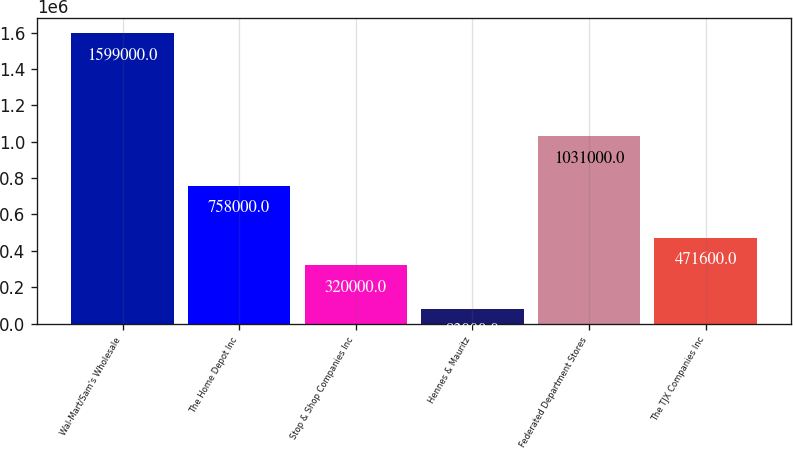<chart> <loc_0><loc_0><loc_500><loc_500><bar_chart><fcel>Wal-Mart/Sam's Wholesale<fcel>The Home Depot Inc<fcel>Stop & Shop Companies Inc<fcel>Hennes & Mauritz<fcel>Federated Department Stores<fcel>The TJX Companies Inc<nl><fcel>1.599e+06<fcel>758000<fcel>320000<fcel>83000<fcel>1.031e+06<fcel>471600<nl></chart> 